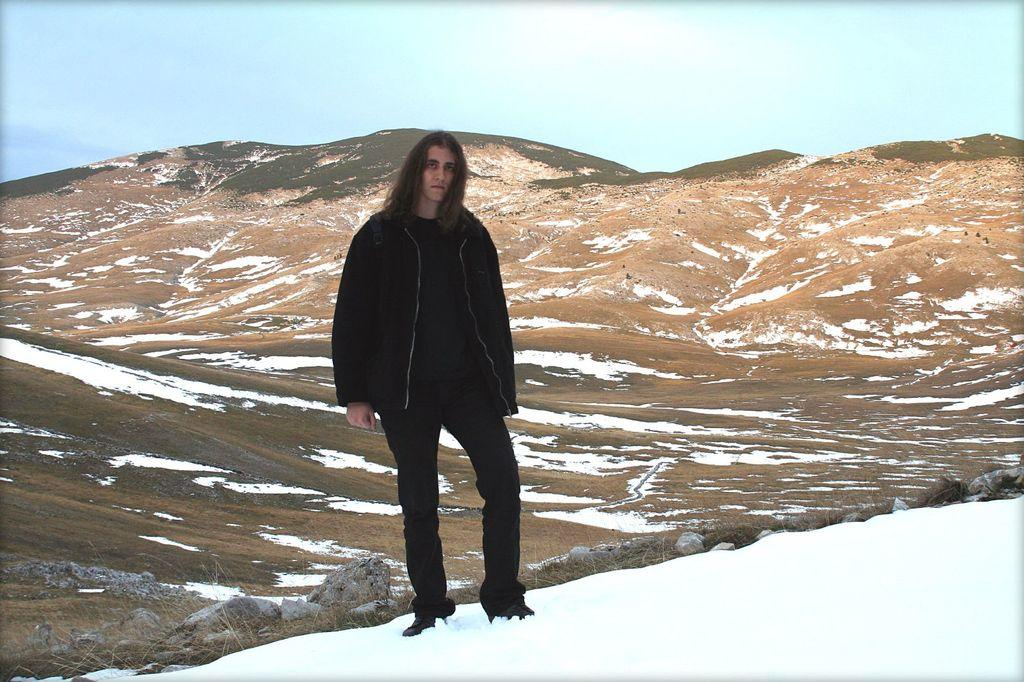What can be seen in the foreground of the image? In the foreground of the image, there are rocks, plants, snow, and a person. What is the terrain like in the middle of the image? In the middle of the image, there are hills and snow. What is visible at the top of the image? The sky is visible at the top of the image. What type of tools does the carpenter have in the image? There is no carpenter present in the image. How many sticks are visible in the image? There are no sticks visible in the image. 